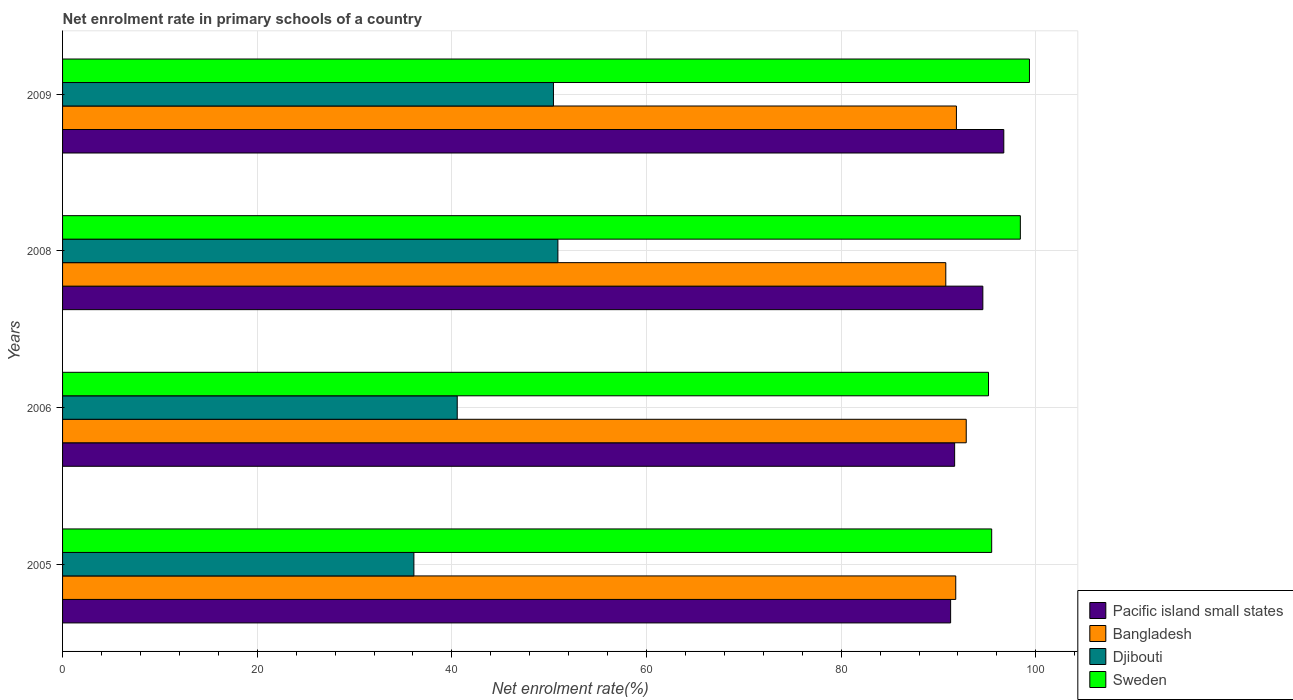How many groups of bars are there?
Ensure brevity in your answer.  4. Are the number of bars per tick equal to the number of legend labels?
Provide a short and direct response. Yes. How many bars are there on the 2nd tick from the top?
Your answer should be very brief. 4. What is the label of the 4th group of bars from the top?
Offer a very short reply. 2005. In how many cases, is the number of bars for a given year not equal to the number of legend labels?
Give a very brief answer. 0. What is the net enrolment rate in primary schools in Sweden in 2009?
Ensure brevity in your answer.  99.35. Across all years, what is the maximum net enrolment rate in primary schools in Djibouti?
Offer a terse response. 50.9. Across all years, what is the minimum net enrolment rate in primary schools in Sweden?
Offer a very short reply. 95.14. In which year was the net enrolment rate in primary schools in Pacific island small states maximum?
Your answer should be compact. 2009. What is the total net enrolment rate in primary schools in Sweden in the graph?
Offer a terse response. 388.38. What is the difference between the net enrolment rate in primary schools in Sweden in 2006 and that in 2009?
Keep it short and to the point. -4.21. What is the difference between the net enrolment rate in primary schools in Bangladesh in 2009 and the net enrolment rate in primary schools in Djibouti in 2008?
Your response must be concise. 40.95. What is the average net enrolment rate in primary schools in Bangladesh per year?
Provide a short and direct response. 91.81. In the year 2009, what is the difference between the net enrolment rate in primary schools in Bangladesh and net enrolment rate in primary schools in Sweden?
Provide a succinct answer. -7.51. In how many years, is the net enrolment rate in primary schools in Djibouti greater than 76 %?
Offer a terse response. 0. What is the ratio of the net enrolment rate in primary schools in Pacific island small states in 2006 to that in 2009?
Your response must be concise. 0.95. Is the net enrolment rate in primary schools in Bangladesh in 2006 less than that in 2009?
Provide a succinct answer. No. What is the difference between the highest and the second highest net enrolment rate in primary schools in Sweden?
Your response must be concise. 0.94. What is the difference between the highest and the lowest net enrolment rate in primary schools in Pacific island small states?
Offer a terse response. 5.46. In how many years, is the net enrolment rate in primary schools in Pacific island small states greater than the average net enrolment rate in primary schools in Pacific island small states taken over all years?
Your response must be concise. 2. What does the 3rd bar from the bottom in 2006 represents?
Your response must be concise. Djibouti. How many bars are there?
Offer a terse response. 16. How many years are there in the graph?
Provide a succinct answer. 4. What is the difference between two consecutive major ticks on the X-axis?
Make the answer very short. 20. Are the values on the major ticks of X-axis written in scientific E-notation?
Your response must be concise. No. Does the graph contain grids?
Ensure brevity in your answer.  Yes. Where does the legend appear in the graph?
Offer a terse response. Bottom right. What is the title of the graph?
Provide a short and direct response. Net enrolment rate in primary schools of a country. What is the label or title of the X-axis?
Provide a short and direct response. Net enrolment rate(%). What is the label or title of the Y-axis?
Provide a succinct answer. Years. What is the Net enrolment rate(%) in Pacific island small states in 2005?
Provide a succinct answer. 91.25. What is the Net enrolment rate(%) of Bangladesh in 2005?
Ensure brevity in your answer.  91.78. What is the Net enrolment rate(%) of Djibouti in 2005?
Make the answer very short. 36.1. What is the Net enrolment rate(%) of Sweden in 2005?
Give a very brief answer. 95.47. What is the Net enrolment rate(%) of Pacific island small states in 2006?
Your answer should be very brief. 91.66. What is the Net enrolment rate(%) of Bangladesh in 2006?
Provide a succinct answer. 92.85. What is the Net enrolment rate(%) in Djibouti in 2006?
Keep it short and to the point. 40.55. What is the Net enrolment rate(%) of Sweden in 2006?
Keep it short and to the point. 95.14. What is the Net enrolment rate(%) of Pacific island small states in 2008?
Your answer should be very brief. 94.56. What is the Net enrolment rate(%) in Bangladesh in 2008?
Offer a very short reply. 90.75. What is the Net enrolment rate(%) in Djibouti in 2008?
Provide a short and direct response. 50.9. What is the Net enrolment rate(%) of Sweden in 2008?
Make the answer very short. 98.41. What is the Net enrolment rate(%) of Pacific island small states in 2009?
Provide a short and direct response. 96.71. What is the Net enrolment rate(%) of Bangladesh in 2009?
Offer a very short reply. 91.84. What is the Net enrolment rate(%) of Djibouti in 2009?
Give a very brief answer. 50.44. What is the Net enrolment rate(%) in Sweden in 2009?
Give a very brief answer. 99.35. Across all years, what is the maximum Net enrolment rate(%) of Pacific island small states?
Your response must be concise. 96.71. Across all years, what is the maximum Net enrolment rate(%) of Bangladesh?
Your answer should be very brief. 92.85. Across all years, what is the maximum Net enrolment rate(%) of Djibouti?
Offer a very short reply. 50.9. Across all years, what is the maximum Net enrolment rate(%) in Sweden?
Make the answer very short. 99.35. Across all years, what is the minimum Net enrolment rate(%) in Pacific island small states?
Offer a terse response. 91.25. Across all years, what is the minimum Net enrolment rate(%) in Bangladesh?
Make the answer very short. 90.75. Across all years, what is the minimum Net enrolment rate(%) in Djibouti?
Offer a very short reply. 36.1. Across all years, what is the minimum Net enrolment rate(%) of Sweden?
Give a very brief answer. 95.14. What is the total Net enrolment rate(%) in Pacific island small states in the graph?
Your response must be concise. 374.18. What is the total Net enrolment rate(%) of Bangladesh in the graph?
Provide a succinct answer. 367.23. What is the total Net enrolment rate(%) in Djibouti in the graph?
Offer a very short reply. 177.99. What is the total Net enrolment rate(%) in Sweden in the graph?
Your response must be concise. 388.38. What is the difference between the Net enrolment rate(%) in Pacific island small states in 2005 and that in 2006?
Your answer should be compact. -0.41. What is the difference between the Net enrolment rate(%) in Bangladesh in 2005 and that in 2006?
Offer a terse response. -1.08. What is the difference between the Net enrolment rate(%) in Djibouti in 2005 and that in 2006?
Give a very brief answer. -4.45. What is the difference between the Net enrolment rate(%) of Sweden in 2005 and that in 2006?
Ensure brevity in your answer.  0.33. What is the difference between the Net enrolment rate(%) of Pacific island small states in 2005 and that in 2008?
Make the answer very short. -3.31. What is the difference between the Net enrolment rate(%) of Djibouti in 2005 and that in 2008?
Give a very brief answer. -14.8. What is the difference between the Net enrolment rate(%) in Sweden in 2005 and that in 2008?
Give a very brief answer. -2.94. What is the difference between the Net enrolment rate(%) in Pacific island small states in 2005 and that in 2009?
Make the answer very short. -5.46. What is the difference between the Net enrolment rate(%) in Bangladesh in 2005 and that in 2009?
Offer a very short reply. -0.07. What is the difference between the Net enrolment rate(%) in Djibouti in 2005 and that in 2009?
Provide a short and direct response. -14.34. What is the difference between the Net enrolment rate(%) of Sweden in 2005 and that in 2009?
Ensure brevity in your answer.  -3.88. What is the difference between the Net enrolment rate(%) in Pacific island small states in 2006 and that in 2008?
Your response must be concise. -2.9. What is the difference between the Net enrolment rate(%) of Bangladesh in 2006 and that in 2008?
Your answer should be compact. 2.1. What is the difference between the Net enrolment rate(%) in Djibouti in 2006 and that in 2008?
Provide a succinct answer. -10.34. What is the difference between the Net enrolment rate(%) in Sweden in 2006 and that in 2008?
Give a very brief answer. -3.27. What is the difference between the Net enrolment rate(%) in Pacific island small states in 2006 and that in 2009?
Offer a terse response. -5.05. What is the difference between the Net enrolment rate(%) of Djibouti in 2006 and that in 2009?
Your response must be concise. -9.89. What is the difference between the Net enrolment rate(%) in Sweden in 2006 and that in 2009?
Provide a short and direct response. -4.21. What is the difference between the Net enrolment rate(%) of Pacific island small states in 2008 and that in 2009?
Offer a very short reply. -2.15. What is the difference between the Net enrolment rate(%) of Bangladesh in 2008 and that in 2009?
Give a very brief answer. -1.09. What is the difference between the Net enrolment rate(%) of Djibouti in 2008 and that in 2009?
Your response must be concise. 0.46. What is the difference between the Net enrolment rate(%) in Sweden in 2008 and that in 2009?
Offer a very short reply. -0.94. What is the difference between the Net enrolment rate(%) of Pacific island small states in 2005 and the Net enrolment rate(%) of Bangladesh in 2006?
Provide a short and direct response. -1.6. What is the difference between the Net enrolment rate(%) of Pacific island small states in 2005 and the Net enrolment rate(%) of Djibouti in 2006?
Offer a terse response. 50.7. What is the difference between the Net enrolment rate(%) of Pacific island small states in 2005 and the Net enrolment rate(%) of Sweden in 2006?
Keep it short and to the point. -3.89. What is the difference between the Net enrolment rate(%) of Bangladesh in 2005 and the Net enrolment rate(%) of Djibouti in 2006?
Provide a succinct answer. 51.22. What is the difference between the Net enrolment rate(%) of Bangladesh in 2005 and the Net enrolment rate(%) of Sweden in 2006?
Offer a very short reply. -3.37. What is the difference between the Net enrolment rate(%) of Djibouti in 2005 and the Net enrolment rate(%) of Sweden in 2006?
Provide a short and direct response. -59.04. What is the difference between the Net enrolment rate(%) in Pacific island small states in 2005 and the Net enrolment rate(%) in Bangladesh in 2008?
Keep it short and to the point. 0.5. What is the difference between the Net enrolment rate(%) of Pacific island small states in 2005 and the Net enrolment rate(%) of Djibouti in 2008?
Your answer should be compact. 40.35. What is the difference between the Net enrolment rate(%) of Pacific island small states in 2005 and the Net enrolment rate(%) of Sweden in 2008?
Provide a short and direct response. -7.16. What is the difference between the Net enrolment rate(%) in Bangladesh in 2005 and the Net enrolment rate(%) in Djibouti in 2008?
Your answer should be very brief. 40.88. What is the difference between the Net enrolment rate(%) of Bangladesh in 2005 and the Net enrolment rate(%) of Sweden in 2008?
Provide a succinct answer. -6.64. What is the difference between the Net enrolment rate(%) of Djibouti in 2005 and the Net enrolment rate(%) of Sweden in 2008?
Your answer should be very brief. -62.31. What is the difference between the Net enrolment rate(%) in Pacific island small states in 2005 and the Net enrolment rate(%) in Bangladesh in 2009?
Your answer should be compact. -0.6. What is the difference between the Net enrolment rate(%) in Pacific island small states in 2005 and the Net enrolment rate(%) in Djibouti in 2009?
Give a very brief answer. 40.81. What is the difference between the Net enrolment rate(%) in Pacific island small states in 2005 and the Net enrolment rate(%) in Sweden in 2009?
Offer a very short reply. -8.1. What is the difference between the Net enrolment rate(%) of Bangladesh in 2005 and the Net enrolment rate(%) of Djibouti in 2009?
Your answer should be very brief. 41.34. What is the difference between the Net enrolment rate(%) in Bangladesh in 2005 and the Net enrolment rate(%) in Sweden in 2009?
Provide a short and direct response. -7.57. What is the difference between the Net enrolment rate(%) of Djibouti in 2005 and the Net enrolment rate(%) of Sweden in 2009?
Your answer should be very brief. -63.25. What is the difference between the Net enrolment rate(%) of Pacific island small states in 2006 and the Net enrolment rate(%) of Bangladesh in 2008?
Offer a terse response. 0.91. What is the difference between the Net enrolment rate(%) of Pacific island small states in 2006 and the Net enrolment rate(%) of Djibouti in 2008?
Provide a succinct answer. 40.77. What is the difference between the Net enrolment rate(%) in Pacific island small states in 2006 and the Net enrolment rate(%) in Sweden in 2008?
Your response must be concise. -6.75. What is the difference between the Net enrolment rate(%) in Bangladesh in 2006 and the Net enrolment rate(%) in Djibouti in 2008?
Your answer should be very brief. 41.96. What is the difference between the Net enrolment rate(%) in Bangladesh in 2006 and the Net enrolment rate(%) in Sweden in 2008?
Your answer should be very brief. -5.56. What is the difference between the Net enrolment rate(%) of Djibouti in 2006 and the Net enrolment rate(%) of Sweden in 2008?
Provide a short and direct response. -57.86. What is the difference between the Net enrolment rate(%) in Pacific island small states in 2006 and the Net enrolment rate(%) in Bangladesh in 2009?
Give a very brief answer. -0.18. What is the difference between the Net enrolment rate(%) of Pacific island small states in 2006 and the Net enrolment rate(%) of Djibouti in 2009?
Your response must be concise. 41.22. What is the difference between the Net enrolment rate(%) of Pacific island small states in 2006 and the Net enrolment rate(%) of Sweden in 2009?
Your answer should be compact. -7.69. What is the difference between the Net enrolment rate(%) of Bangladesh in 2006 and the Net enrolment rate(%) of Djibouti in 2009?
Offer a very short reply. 42.41. What is the difference between the Net enrolment rate(%) in Bangladesh in 2006 and the Net enrolment rate(%) in Sweden in 2009?
Your answer should be compact. -6.5. What is the difference between the Net enrolment rate(%) of Djibouti in 2006 and the Net enrolment rate(%) of Sweden in 2009?
Keep it short and to the point. -58.8. What is the difference between the Net enrolment rate(%) of Pacific island small states in 2008 and the Net enrolment rate(%) of Bangladesh in 2009?
Offer a very short reply. 2.72. What is the difference between the Net enrolment rate(%) in Pacific island small states in 2008 and the Net enrolment rate(%) in Djibouti in 2009?
Provide a succinct answer. 44.12. What is the difference between the Net enrolment rate(%) in Pacific island small states in 2008 and the Net enrolment rate(%) in Sweden in 2009?
Your answer should be compact. -4.79. What is the difference between the Net enrolment rate(%) in Bangladesh in 2008 and the Net enrolment rate(%) in Djibouti in 2009?
Your answer should be compact. 40.31. What is the difference between the Net enrolment rate(%) in Bangladesh in 2008 and the Net enrolment rate(%) in Sweden in 2009?
Your response must be concise. -8.6. What is the difference between the Net enrolment rate(%) in Djibouti in 2008 and the Net enrolment rate(%) in Sweden in 2009?
Offer a terse response. -48.45. What is the average Net enrolment rate(%) in Pacific island small states per year?
Give a very brief answer. 93.55. What is the average Net enrolment rate(%) of Bangladesh per year?
Make the answer very short. 91.81. What is the average Net enrolment rate(%) of Djibouti per year?
Give a very brief answer. 44.5. What is the average Net enrolment rate(%) in Sweden per year?
Give a very brief answer. 97.09. In the year 2005, what is the difference between the Net enrolment rate(%) in Pacific island small states and Net enrolment rate(%) in Bangladesh?
Offer a terse response. -0.53. In the year 2005, what is the difference between the Net enrolment rate(%) of Pacific island small states and Net enrolment rate(%) of Djibouti?
Offer a very short reply. 55.15. In the year 2005, what is the difference between the Net enrolment rate(%) in Pacific island small states and Net enrolment rate(%) in Sweden?
Offer a terse response. -4.22. In the year 2005, what is the difference between the Net enrolment rate(%) in Bangladesh and Net enrolment rate(%) in Djibouti?
Provide a short and direct response. 55.68. In the year 2005, what is the difference between the Net enrolment rate(%) in Bangladesh and Net enrolment rate(%) in Sweden?
Make the answer very short. -3.69. In the year 2005, what is the difference between the Net enrolment rate(%) of Djibouti and Net enrolment rate(%) of Sweden?
Offer a terse response. -59.37. In the year 2006, what is the difference between the Net enrolment rate(%) in Pacific island small states and Net enrolment rate(%) in Bangladesh?
Give a very brief answer. -1.19. In the year 2006, what is the difference between the Net enrolment rate(%) of Pacific island small states and Net enrolment rate(%) of Djibouti?
Offer a very short reply. 51.11. In the year 2006, what is the difference between the Net enrolment rate(%) in Pacific island small states and Net enrolment rate(%) in Sweden?
Provide a succinct answer. -3.48. In the year 2006, what is the difference between the Net enrolment rate(%) of Bangladesh and Net enrolment rate(%) of Djibouti?
Give a very brief answer. 52.3. In the year 2006, what is the difference between the Net enrolment rate(%) in Bangladesh and Net enrolment rate(%) in Sweden?
Keep it short and to the point. -2.29. In the year 2006, what is the difference between the Net enrolment rate(%) in Djibouti and Net enrolment rate(%) in Sweden?
Offer a very short reply. -54.59. In the year 2008, what is the difference between the Net enrolment rate(%) of Pacific island small states and Net enrolment rate(%) of Bangladesh?
Your answer should be very brief. 3.81. In the year 2008, what is the difference between the Net enrolment rate(%) in Pacific island small states and Net enrolment rate(%) in Djibouti?
Your response must be concise. 43.67. In the year 2008, what is the difference between the Net enrolment rate(%) of Pacific island small states and Net enrolment rate(%) of Sweden?
Make the answer very short. -3.85. In the year 2008, what is the difference between the Net enrolment rate(%) in Bangladesh and Net enrolment rate(%) in Djibouti?
Provide a succinct answer. 39.86. In the year 2008, what is the difference between the Net enrolment rate(%) of Bangladesh and Net enrolment rate(%) of Sweden?
Make the answer very short. -7.66. In the year 2008, what is the difference between the Net enrolment rate(%) of Djibouti and Net enrolment rate(%) of Sweden?
Give a very brief answer. -47.52. In the year 2009, what is the difference between the Net enrolment rate(%) in Pacific island small states and Net enrolment rate(%) in Bangladesh?
Ensure brevity in your answer.  4.87. In the year 2009, what is the difference between the Net enrolment rate(%) in Pacific island small states and Net enrolment rate(%) in Djibouti?
Provide a short and direct response. 46.27. In the year 2009, what is the difference between the Net enrolment rate(%) of Pacific island small states and Net enrolment rate(%) of Sweden?
Provide a short and direct response. -2.64. In the year 2009, what is the difference between the Net enrolment rate(%) of Bangladesh and Net enrolment rate(%) of Djibouti?
Give a very brief answer. 41.41. In the year 2009, what is the difference between the Net enrolment rate(%) in Bangladesh and Net enrolment rate(%) in Sweden?
Give a very brief answer. -7.51. In the year 2009, what is the difference between the Net enrolment rate(%) of Djibouti and Net enrolment rate(%) of Sweden?
Make the answer very short. -48.91. What is the ratio of the Net enrolment rate(%) of Bangladesh in 2005 to that in 2006?
Offer a very short reply. 0.99. What is the ratio of the Net enrolment rate(%) in Djibouti in 2005 to that in 2006?
Your answer should be compact. 0.89. What is the ratio of the Net enrolment rate(%) in Bangladesh in 2005 to that in 2008?
Your response must be concise. 1.01. What is the ratio of the Net enrolment rate(%) of Djibouti in 2005 to that in 2008?
Give a very brief answer. 0.71. What is the ratio of the Net enrolment rate(%) in Sweden in 2005 to that in 2008?
Make the answer very short. 0.97. What is the ratio of the Net enrolment rate(%) of Pacific island small states in 2005 to that in 2009?
Your answer should be very brief. 0.94. What is the ratio of the Net enrolment rate(%) in Djibouti in 2005 to that in 2009?
Make the answer very short. 0.72. What is the ratio of the Net enrolment rate(%) in Sweden in 2005 to that in 2009?
Offer a very short reply. 0.96. What is the ratio of the Net enrolment rate(%) of Pacific island small states in 2006 to that in 2008?
Ensure brevity in your answer.  0.97. What is the ratio of the Net enrolment rate(%) of Bangladesh in 2006 to that in 2008?
Offer a terse response. 1.02. What is the ratio of the Net enrolment rate(%) of Djibouti in 2006 to that in 2008?
Your response must be concise. 0.8. What is the ratio of the Net enrolment rate(%) of Sweden in 2006 to that in 2008?
Your response must be concise. 0.97. What is the ratio of the Net enrolment rate(%) in Pacific island small states in 2006 to that in 2009?
Provide a succinct answer. 0.95. What is the ratio of the Net enrolment rate(%) in Bangladesh in 2006 to that in 2009?
Ensure brevity in your answer.  1.01. What is the ratio of the Net enrolment rate(%) in Djibouti in 2006 to that in 2009?
Your answer should be very brief. 0.8. What is the ratio of the Net enrolment rate(%) in Sweden in 2006 to that in 2009?
Your response must be concise. 0.96. What is the ratio of the Net enrolment rate(%) of Pacific island small states in 2008 to that in 2009?
Offer a terse response. 0.98. What is the ratio of the Net enrolment rate(%) of Bangladesh in 2008 to that in 2009?
Offer a very short reply. 0.99. What is the ratio of the Net enrolment rate(%) in Djibouti in 2008 to that in 2009?
Your answer should be compact. 1.01. What is the ratio of the Net enrolment rate(%) of Sweden in 2008 to that in 2009?
Your answer should be compact. 0.99. What is the difference between the highest and the second highest Net enrolment rate(%) of Pacific island small states?
Your response must be concise. 2.15. What is the difference between the highest and the second highest Net enrolment rate(%) in Bangladesh?
Your answer should be compact. 1.01. What is the difference between the highest and the second highest Net enrolment rate(%) in Djibouti?
Your answer should be compact. 0.46. What is the difference between the highest and the second highest Net enrolment rate(%) of Sweden?
Ensure brevity in your answer.  0.94. What is the difference between the highest and the lowest Net enrolment rate(%) of Pacific island small states?
Make the answer very short. 5.46. What is the difference between the highest and the lowest Net enrolment rate(%) of Bangladesh?
Your response must be concise. 2.1. What is the difference between the highest and the lowest Net enrolment rate(%) in Djibouti?
Provide a short and direct response. 14.8. What is the difference between the highest and the lowest Net enrolment rate(%) of Sweden?
Make the answer very short. 4.21. 